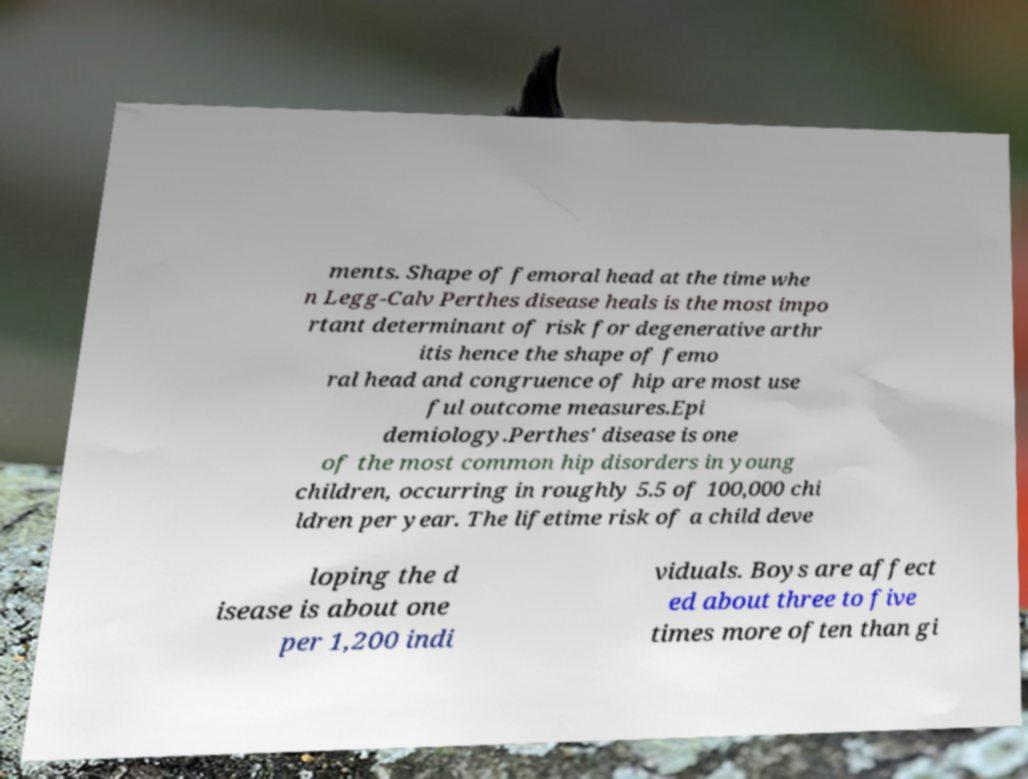Please identify and transcribe the text found in this image. ments. Shape of femoral head at the time whe n Legg-Calv Perthes disease heals is the most impo rtant determinant of risk for degenerative arthr itis hence the shape of femo ral head and congruence of hip are most use ful outcome measures.Epi demiology.Perthes' disease is one of the most common hip disorders in young children, occurring in roughly 5.5 of 100,000 chi ldren per year. The lifetime risk of a child deve loping the d isease is about one per 1,200 indi viduals. Boys are affect ed about three to five times more often than gi 